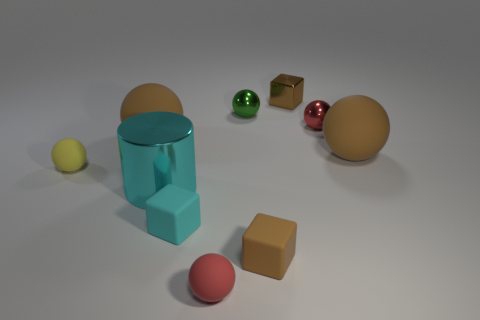Do the green sphere and the red matte object have the same size?
Make the answer very short. Yes. Are there an equal number of large brown rubber balls on the right side of the tiny cyan rubber thing and small green shiny spheres that are behind the metal block?
Your answer should be very brief. No. What shape is the big matte thing that is right of the red shiny ball?
Your answer should be very brief. Sphere. There is a brown rubber thing that is the same size as the cyan block; what shape is it?
Offer a very short reply. Cube. There is a big ball left of the tiny rubber sphere to the right of the tiny yellow rubber ball that is left of the tiny red shiny object; what is its color?
Give a very brief answer. Brown. Is the green object the same shape as the red shiny object?
Your answer should be compact. Yes. Are there an equal number of brown rubber objects behind the large cyan object and rubber balls?
Make the answer very short. No. How many other objects are the same material as the cyan cylinder?
Give a very brief answer. 3. There is a brown block in front of the green ball; is its size the same as the cyan metallic object that is behind the cyan matte block?
Offer a very short reply. No. What number of objects are either cubes that are in front of the yellow object or things on the left side of the green sphere?
Provide a succinct answer. 6. 